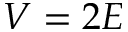Convert formula to latex. <formula><loc_0><loc_0><loc_500><loc_500>V = 2 E</formula> 